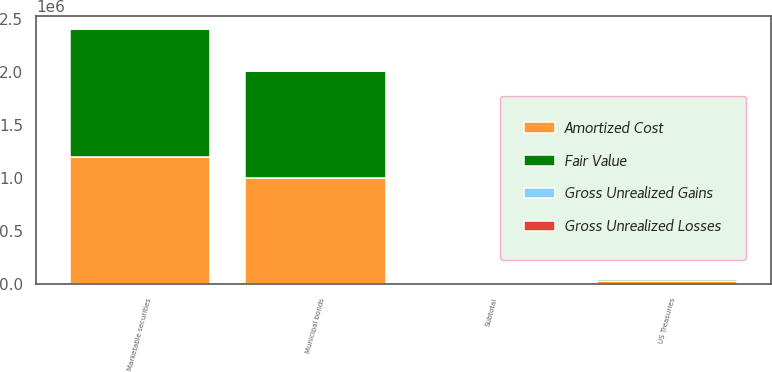Convert chart. <chart><loc_0><loc_0><loc_500><loc_500><stacked_bar_chart><ecel><fcel>US Treasuries<fcel>Municipal bonds<fcel>Subtotal<fcel>Marketable securities<nl><fcel>Fair Value<fcel>25816<fcel>1.00659e+06<fcel>6232<fcel>1.20246e+06<nl><fcel>Gross Unrealized Gains<fcel>129<fcel>17<fcel>366<fcel>366<nl><fcel>Gross Unrealized Losses<fcel>37<fcel>5536<fcel>6240<fcel>6224<nl><fcel>Amortized Cost<fcel>25908<fcel>1.00107e+06<fcel>6232<fcel>1.1966e+06<nl></chart> 